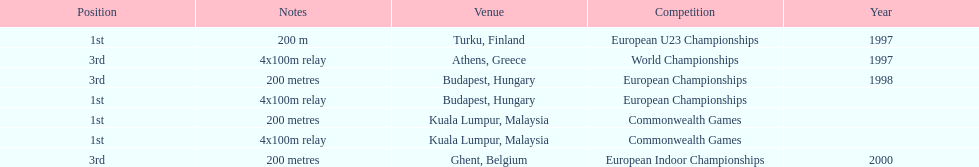How long was the sprint from the european indoor championships competition in 2000? 200 metres. 